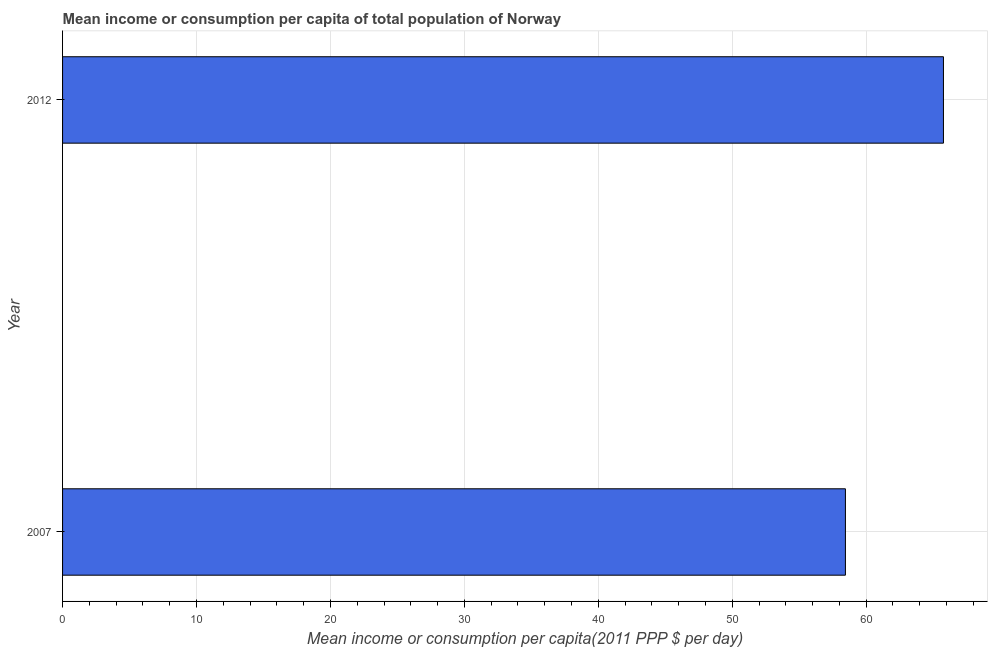Does the graph contain grids?
Your answer should be compact. Yes. What is the title of the graph?
Your answer should be very brief. Mean income or consumption per capita of total population of Norway. What is the label or title of the X-axis?
Keep it short and to the point. Mean income or consumption per capita(2011 PPP $ per day). What is the mean income or consumption in 2007?
Keep it short and to the point. 58.45. Across all years, what is the maximum mean income or consumption?
Make the answer very short. 65.77. Across all years, what is the minimum mean income or consumption?
Make the answer very short. 58.45. What is the sum of the mean income or consumption?
Provide a succinct answer. 124.22. What is the difference between the mean income or consumption in 2007 and 2012?
Provide a succinct answer. -7.32. What is the average mean income or consumption per year?
Your response must be concise. 62.11. What is the median mean income or consumption?
Provide a short and direct response. 62.11. What is the ratio of the mean income or consumption in 2007 to that in 2012?
Provide a succinct answer. 0.89. How many bars are there?
Keep it short and to the point. 2. What is the Mean income or consumption per capita(2011 PPP $ per day) of 2007?
Make the answer very short. 58.45. What is the Mean income or consumption per capita(2011 PPP $ per day) of 2012?
Make the answer very short. 65.77. What is the difference between the Mean income or consumption per capita(2011 PPP $ per day) in 2007 and 2012?
Your response must be concise. -7.32. What is the ratio of the Mean income or consumption per capita(2011 PPP $ per day) in 2007 to that in 2012?
Give a very brief answer. 0.89. 